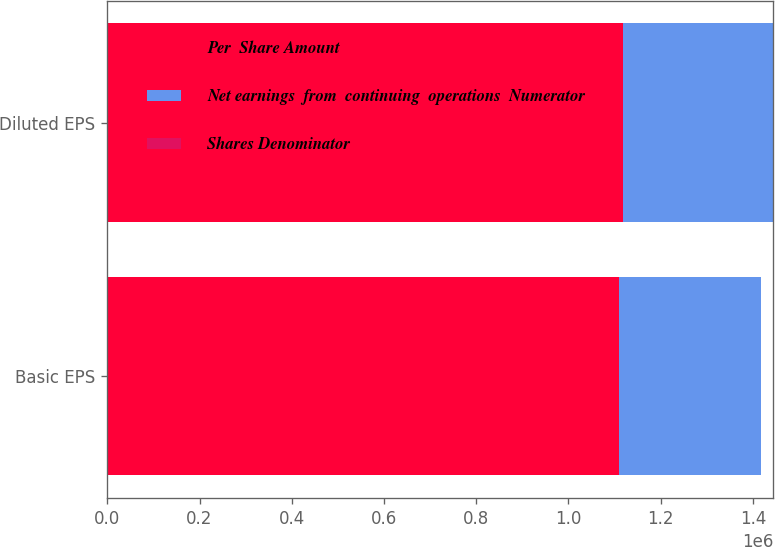<chart> <loc_0><loc_0><loc_500><loc_500><stacked_bar_chart><ecel><fcel>Basic EPS<fcel>Diluted EPS<nl><fcel>Per  Share Amount<fcel>1.10921e+06<fcel>1.11855e+06<nl><fcel>Net earnings  from  continuing  operations  Numerator<fcel>307984<fcel>325251<nl><fcel>Shares Denominator<fcel>3.6<fcel>3.44<nl></chart> 